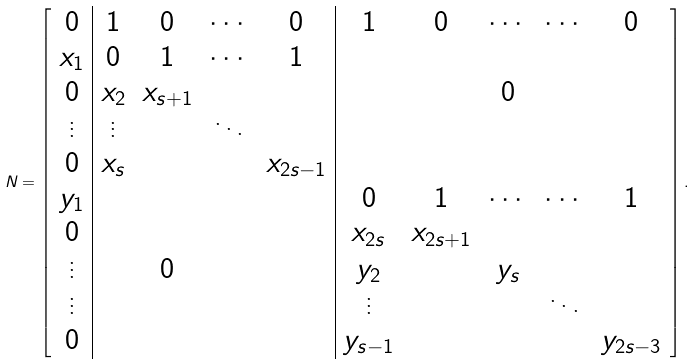Convert formula to latex. <formula><loc_0><loc_0><loc_500><loc_500>N = \left [ \begin{array} { c | c c c c | c c c c c } 0 & 1 & 0 & \cdots & 0 & 1 & 0 & \cdots & \cdots & 0 \\ x _ { 1 } & 0 & 1 & \cdots & 1 & & & & & \\ 0 & x _ { 2 } & x _ { s + 1 } & & & & & 0 & & \\ \vdots & \vdots & & \ddots & & & & & & \\ 0 & x _ { s } & & & x _ { 2 s - 1 } & & & & & \\ y _ { 1 } & & & & & 0 & 1 & \cdots & \cdots & 1 \\ 0 & & & & & x _ { 2 s } & x _ { 2 s + 1 } & & & \\ \vdots & & 0 & & & y _ { 2 } & & y _ { s } & & \\ \vdots & & & & & \vdots & & & \ddots & \\ 0 & & & & & y _ { s - 1 } & & & & y _ { 2 s - 3 } \end{array} \right ] .</formula> 